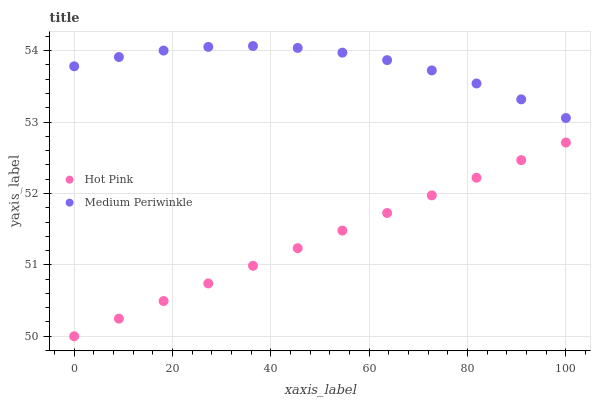Does Hot Pink have the minimum area under the curve?
Answer yes or no. Yes. Does Medium Periwinkle have the maximum area under the curve?
Answer yes or no. Yes. Does Medium Periwinkle have the minimum area under the curve?
Answer yes or no. No. Is Hot Pink the smoothest?
Answer yes or no. Yes. Is Medium Periwinkle the roughest?
Answer yes or no. Yes. Is Medium Periwinkle the smoothest?
Answer yes or no. No. Does Hot Pink have the lowest value?
Answer yes or no. Yes. Does Medium Periwinkle have the lowest value?
Answer yes or no. No. Does Medium Periwinkle have the highest value?
Answer yes or no. Yes. Is Hot Pink less than Medium Periwinkle?
Answer yes or no. Yes. Is Medium Periwinkle greater than Hot Pink?
Answer yes or no. Yes. Does Hot Pink intersect Medium Periwinkle?
Answer yes or no. No. 